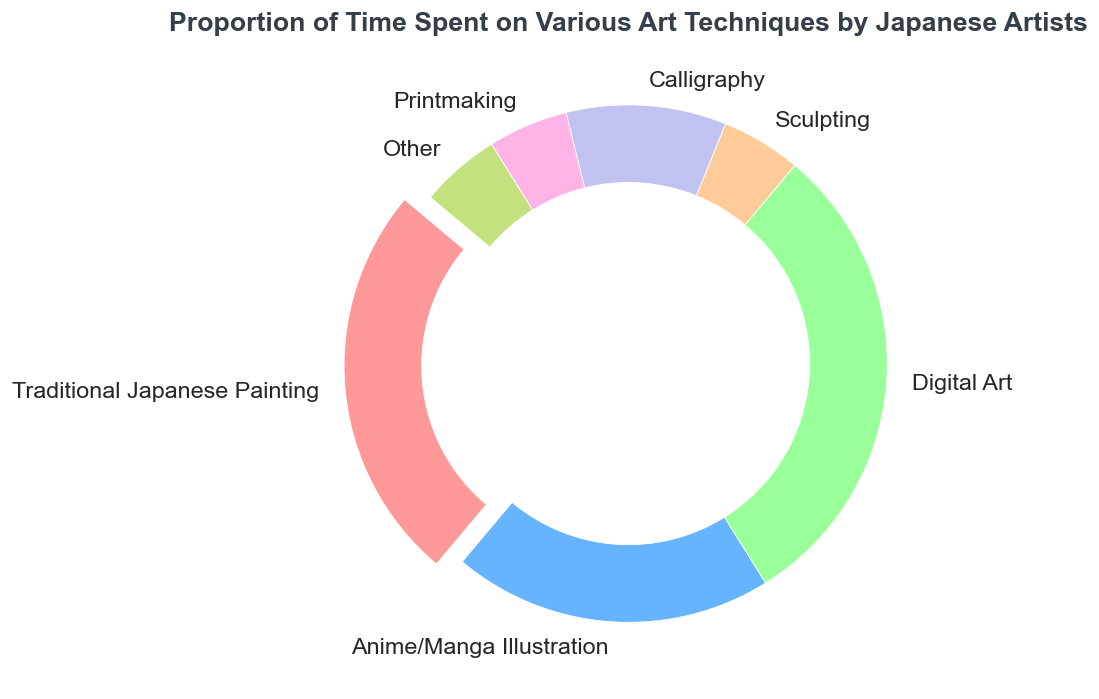What's the dominant art technique according to the chart? The largest segment occupies 30% of the ring chart and is labeled "Digital Art." Therefore, the dominant art technique is Digital Art.
Answer: Digital Art Which segment of the chart represents exactly 10% of the time spent? By referring to the chart, the segment representing 10% is labeled "Calligraphy."
Answer: Calligraphy What's the combined percentage of time spent on Sculpting, Printmaking, and Other techniques? Each of these techniques individually represents 5% of the time spent. Combined, they amount to 5% + 5% + 5% = 15%.
Answer: 15% Which technique do Japanese artists spend the least amount of time on, and how does its proportion compare to the time spent on Traditional Japanese Painting? The least amount of time (5%) is spent on Sculpting, Printmaking, and Other techniques. Traditional Japanese Painting, on the other hand, takes 25% of their time. Therefore, Traditional Japanese Painting receives 20% more time than each of these least time-consuming techniques.
Answer: Sculpting/Printmaking/Other, 20% more What's the ratio of time spent on Anime/Manga Illustration to Calligraphy? Anime/Manga Illustration accounts for 20% of the time, while Calligraphy takes 10%. The ratio is thus 20% / 10% = 2.
Answer: 2 How does the proportion of time spent on Digital Art compare to the combined time spent on Anime/Manga Illustration and Traditional Japanese Painting? Digital Art takes up 30%. Combined, Anime/Manga Illustration (20%) and Traditional Japanese Painting (25%) amount to 45%. Therefore, Digital Art accounts for less time by 45% - 30% = 15%.
Answer: 15% less 